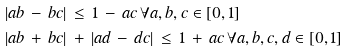<formula> <loc_0><loc_0><loc_500><loc_500>| & a b \, - \, b c | \, \leq \, 1 \, - \, a c \, \forall a , b , c \in [ 0 , 1 ] \\ | & a b \, + \, b c | \, + \, | a d \, - \, d c | \, \leq \, 1 \, + \, a c \, \forall a , b , c , d \in [ 0 , 1 ] \\</formula> 